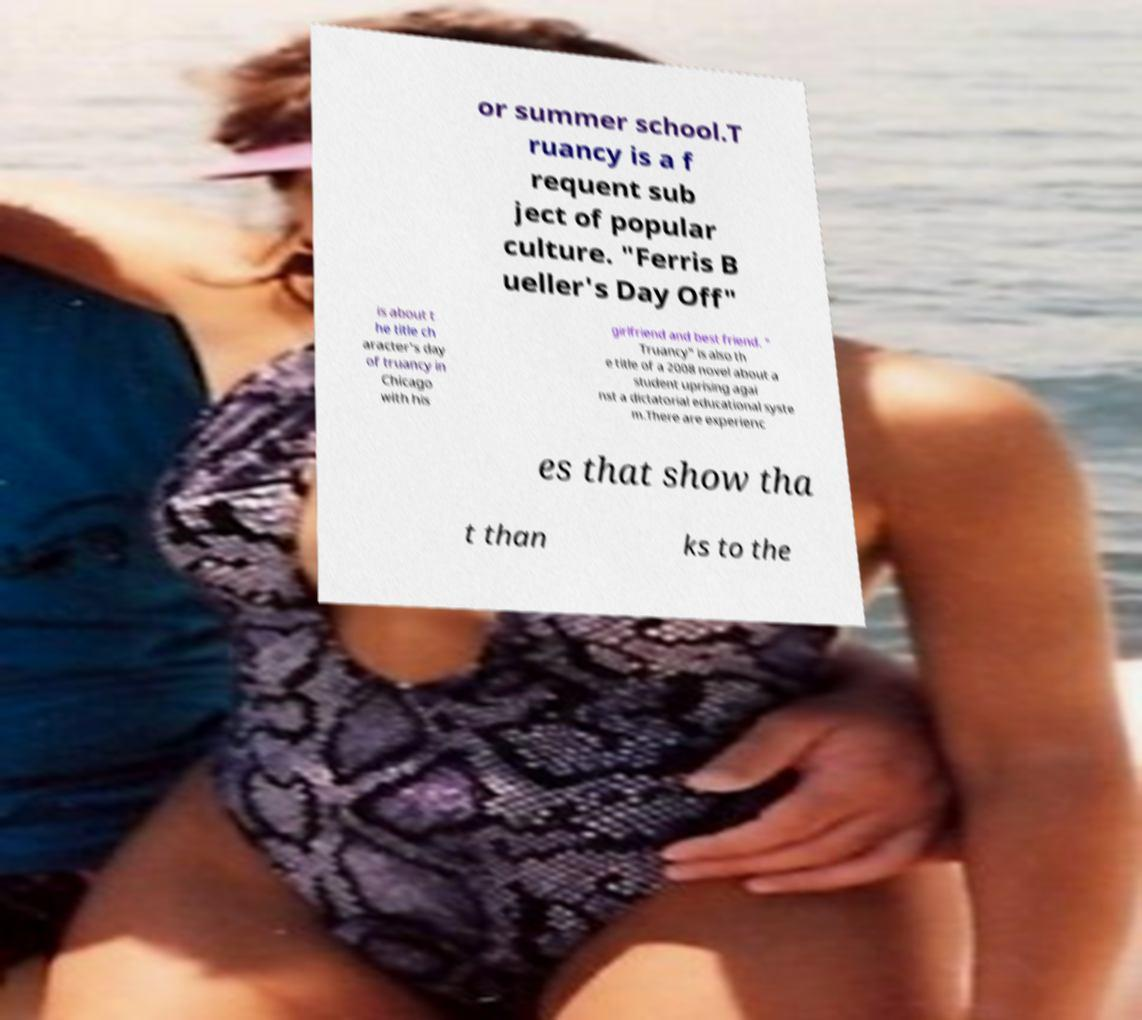Can you read and provide the text displayed in the image?This photo seems to have some interesting text. Can you extract and type it out for me? or summer school.T ruancy is a f requent sub ject of popular culture. "Ferris B ueller's Day Off" is about t he title ch aracter's day of truancy in Chicago with his girlfriend and best friend. " Truancy" is also th e title of a 2008 novel about a student uprising agai nst a dictatorial educational syste m.There are experienc es that show tha t than ks to the 